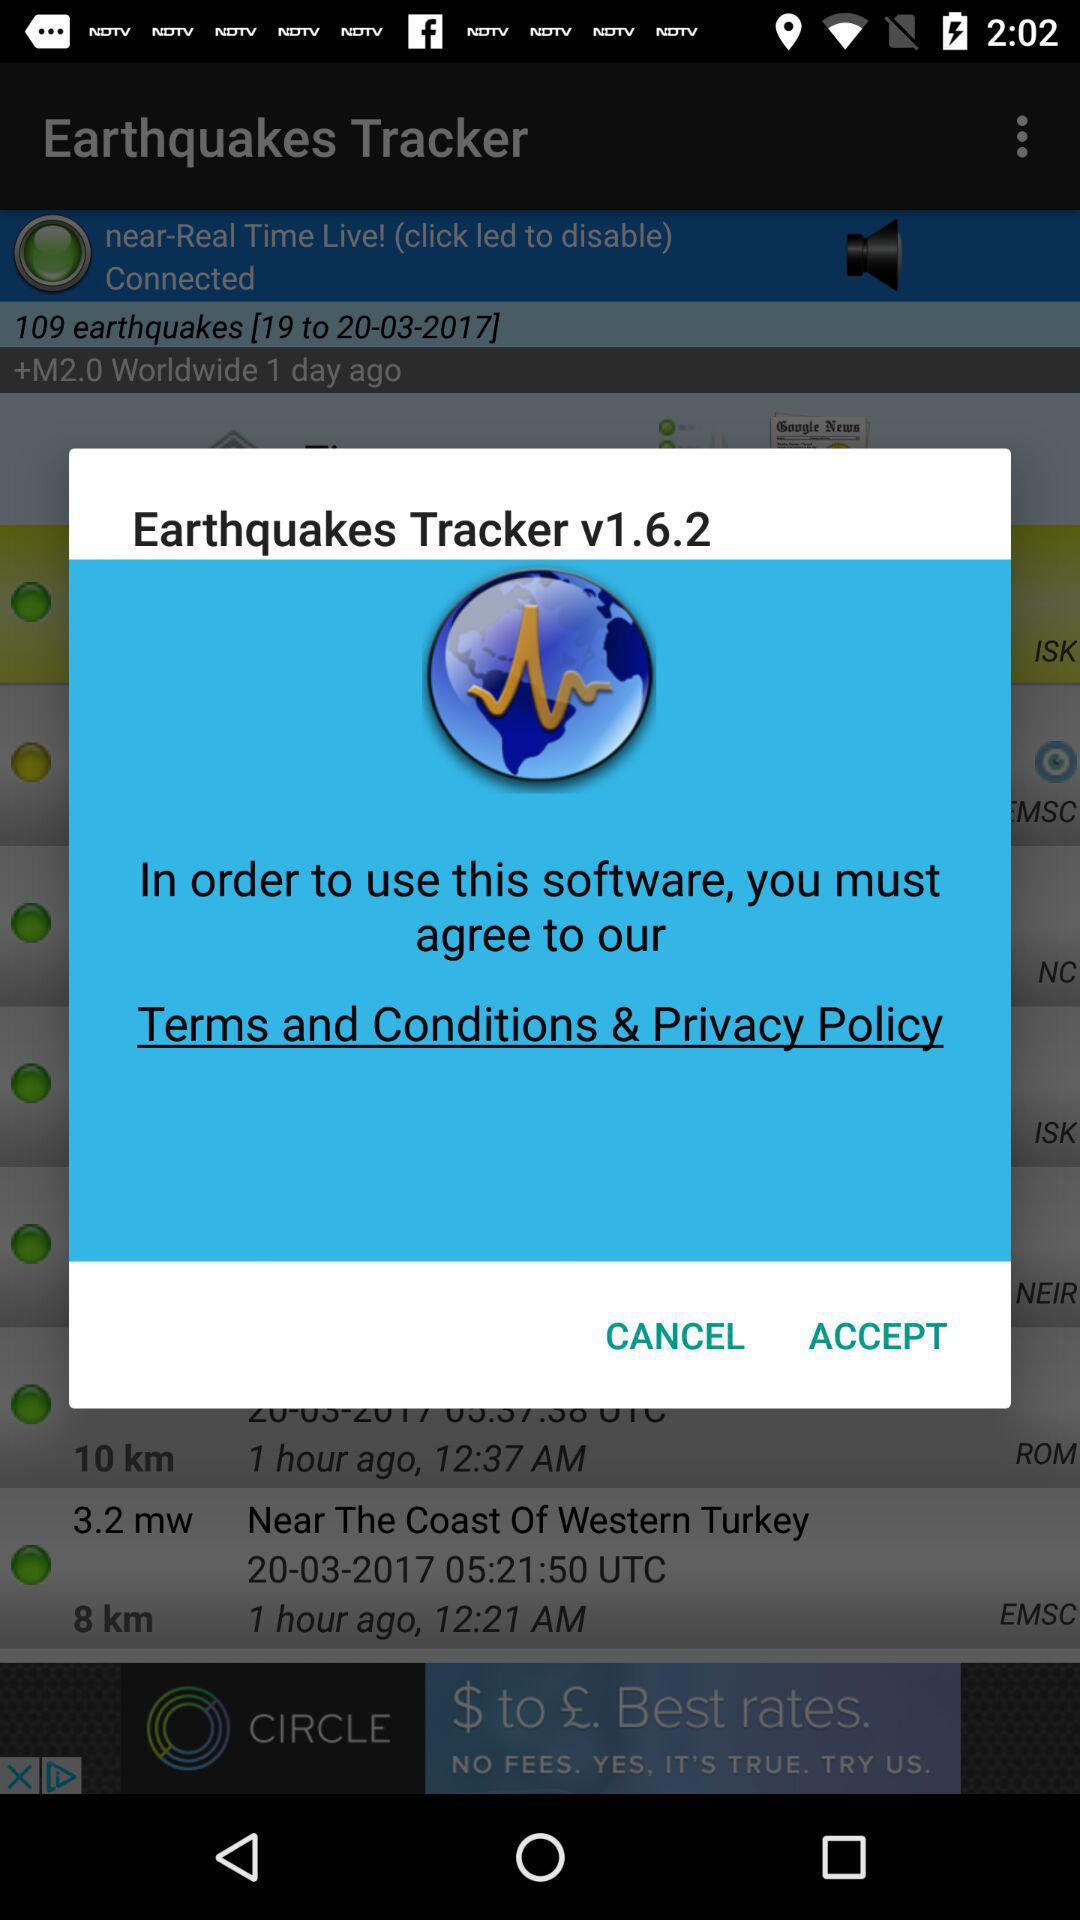What is the application name? The application name is "Earthquakes Tracker". 